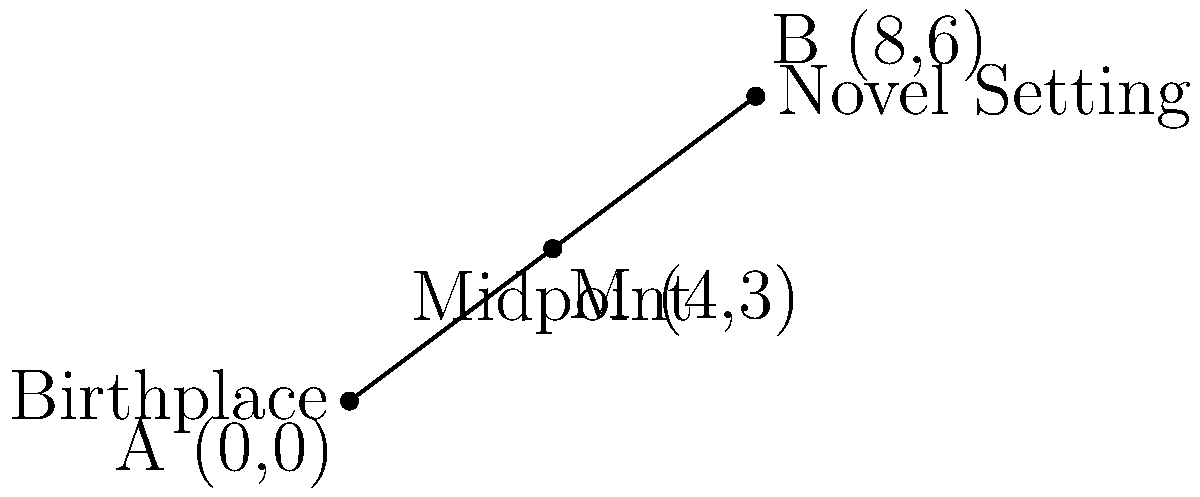As an author, you've often reflected on the journey from your birthplace to the setting of your most famous novel. On a coordinate plane, your birthplace is represented by point A (0,0), and the novel's setting is point B (8,6). What are the coordinates of the midpoint M between these two significant locations in your life? To find the midpoint between two points, we use the midpoint formula:

$$ M = (\frac{x_1 + x_2}{2}, \frac{y_1 + y_2}{2}) $$

Where $(x_1, y_1)$ are the coordinates of the first point and $(x_2, y_2)$ are the coordinates of the second point.

Given:
- Point A (birthplace): $(0, 0)$
- Point B (novel setting): $(8, 6)$

Step 1: Calculate the x-coordinate of the midpoint:
$$ x = \frac{x_1 + x_2}{2} = \frac{0 + 8}{2} = \frac{8}{2} = 4 $$

Step 2: Calculate the y-coordinate of the midpoint:
$$ y = \frac{y_1 + y_2}{2} = \frac{0 + 6}{2} = \frac{6}{2} = 3 $$

Therefore, the coordinates of the midpoint M are (4, 3).
Answer: (4, 3) 